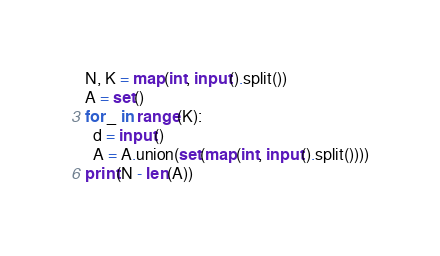<code> <loc_0><loc_0><loc_500><loc_500><_Python_>N, K = map(int, input().split())
A = set()
for _ in range(K):
  d = input()
  A = A.union(set(map(int, input().split())))
print(N - len(A))</code> 